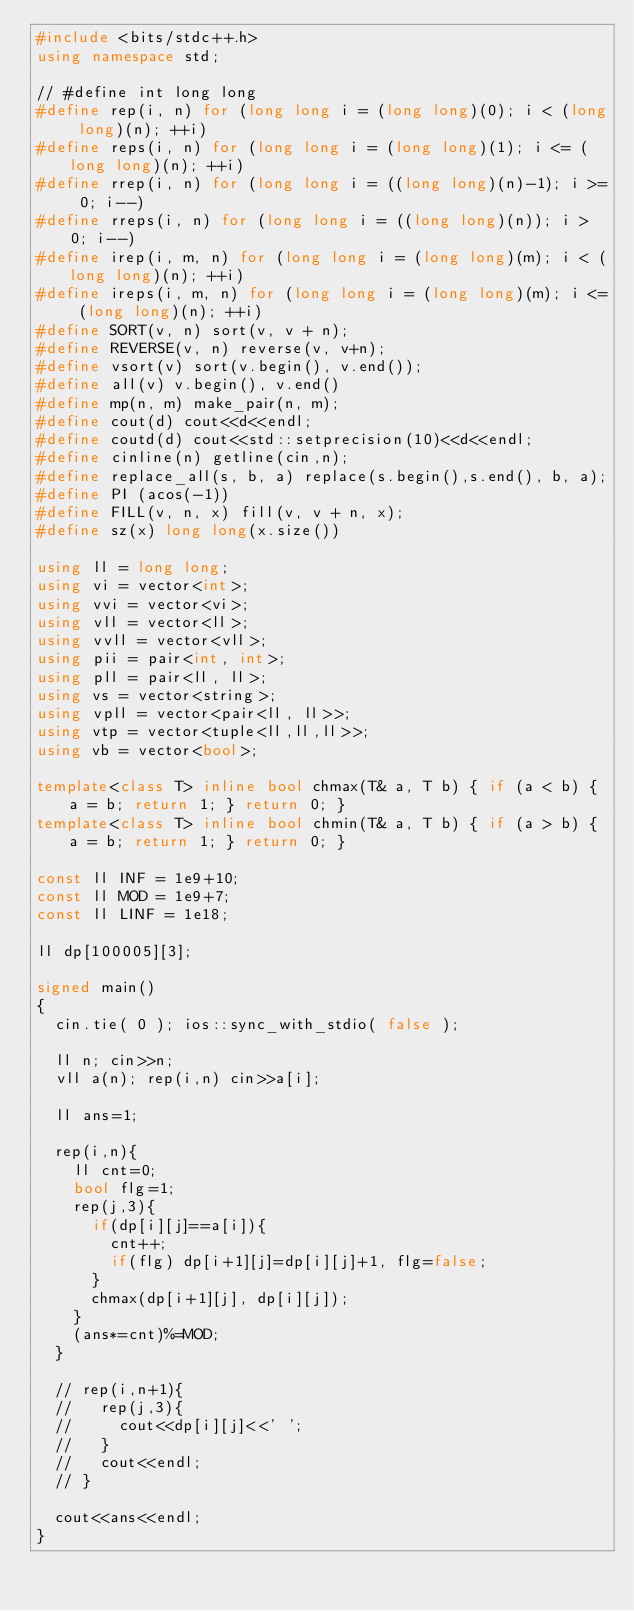<code> <loc_0><loc_0><loc_500><loc_500><_C++_>#include <bits/stdc++.h>
using namespace std;

// #define int long long
#define rep(i, n) for (long long i = (long long)(0); i < (long long)(n); ++i)
#define reps(i, n) for (long long i = (long long)(1); i <= (long long)(n); ++i)
#define rrep(i, n) for (long long i = ((long long)(n)-1); i >= 0; i--)
#define rreps(i, n) for (long long i = ((long long)(n)); i > 0; i--)
#define irep(i, m, n) for (long long i = (long long)(m); i < (long long)(n); ++i)
#define ireps(i, m, n) for (long long i = (long long)(m); i <= (long long)(n); ++i)
#define SORT(v, n) sort(v, v + n);
#define REVERSE(v, n) reverse(v, v+n);
#define vsort(v) sort(v.begin(), v.end());
#define all(v) v.begin(), v.end()
#define mp(n, m) make_pair(n, m);
#define cout(d) cout<<d<<endl;
#define coutd(d) cout<<std::setprecision(10)<<d<<endl;
#define cinline(n) getline(cin,n);
#define replace_all(s, b, a) replace(s.begin(),s.end(), b, a);
#define PI (acos(-1))
#define FILL(v, n, x) fill(v, v + n, x);
#define sz(x) long long(x.size())

using ll = long long;
using vi = vector<int>;
using vvi = vector<vi>;
using vll = vector<ll>;
using vvll = vector<vll>;
using pii = pair<int, int>;
using pll = pair<ll, ll>;
using vs = vector<string>;
using vpll = vector<pair<ll, ll>>;
using vtp = vector<tuple<ll,ll,ll>>;
using vb = vector<bool>;

template<class T> inline bool chmax(T& a, T b) { if (a < b) { a = b; return 1; } return 0; }
template<class T> inline bool chmin(T& a, T b) { if (a > b) { a = b; return 1; } return 0; }

const ll INF = 1e9+10;
const ll MOD = 1e9+7;
const ll LINF = 1e18;

ll dp[100005][3];

signed main()
{
  cin.tie( 0 ); ios::sync_with_stdio( false );
  
  ll n; cin>>n;
  vll a(n); rep(i,n) cin>>a[i];
  
  ll ans=1;
  
  rep(i,n){
    ll cnt=0;
    bool flg=1;
    rep(j,3){
      if(dp[i][j]==a[i]){
        cnt++;
        if(flg) dp[i+1][j]=dp[i][j]+1, flg=false;
      }
      chmax(dp[i+1][j], dp[i][j]);
    }
    (ans*=cnt)%=MOD;
  }
  
  // rep(i,n+1){
  //   rep(j,3){
  //     cout<<dp[i][j]<<' ';
  //   }
  //   cout<<endl;
  // }
  
  cout<<ans<<endl;
}</code> 